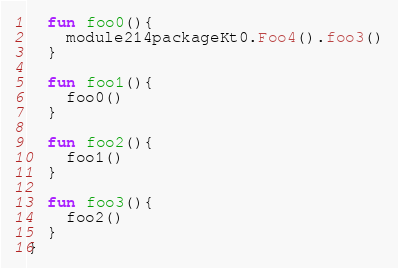<code> <loc_0><loc_0><loc_500><loc_500><_Kotlin_>  fun foo0(){
    module214packageKt0.Foo4().foo3()
  }

  fun foo1(){
    foo0()
  }

  fun foo2(){
    foo1()
  }

  fun foo3(){
    foo2()
  }
}</code> 